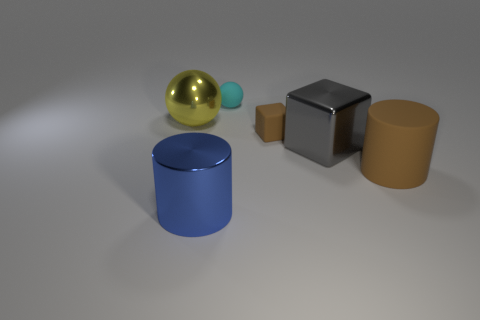Add 1 green rubber things. How many objects exist? 7 Subtract all cylinders. How many objects are left? 4 Subtract all green spheres. Subtract all cyan cylinders. How many spheres are left? 2 Subtract all large shiny cubes. Subtract all small brown rubber objects. How many objects are left? 4 Add 6 matte blocks. How many matte blocks are left? 7 Add 4 large purple cylinders. How many large purple cylinders exist? 4 Subtract 0 gray cylinders. How many objects are left? 6 